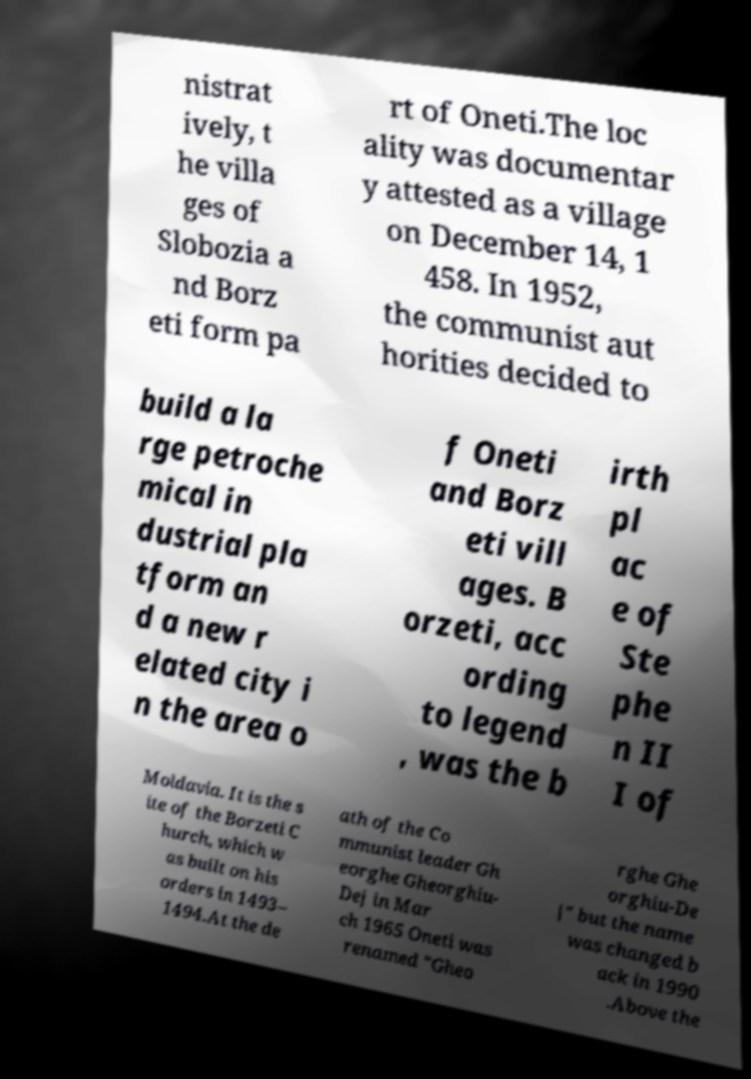Please identify and transcribe the text found in this image. nistrat ively, t he villa ges of Slobozia a nd Borz eti form pa rt of Oneti.The loc ality was documentar y attested as a village on December 14, 1 458. In 1952, the communist aut horities decided to build a la rge petroche mical in dustrial pla tform an d a new r elated city i n the area o f Oneti and Borz eti vill ages. B orzeti, acc ording to legend , was the b irth pl ac e of Ste phe n II I of Moldavia. It is the s ite of the Borzeti C hurch, which w as built on his orders in 1493– 1494.At the de ath of the Co mmunist leader Gh eorghe Gheorghiu- Dej in Mar ch 1965 Oneti was renamed "Gheo rghe Ghe orghiu-De j" but the name was changed b ack in 1990 .Above the 